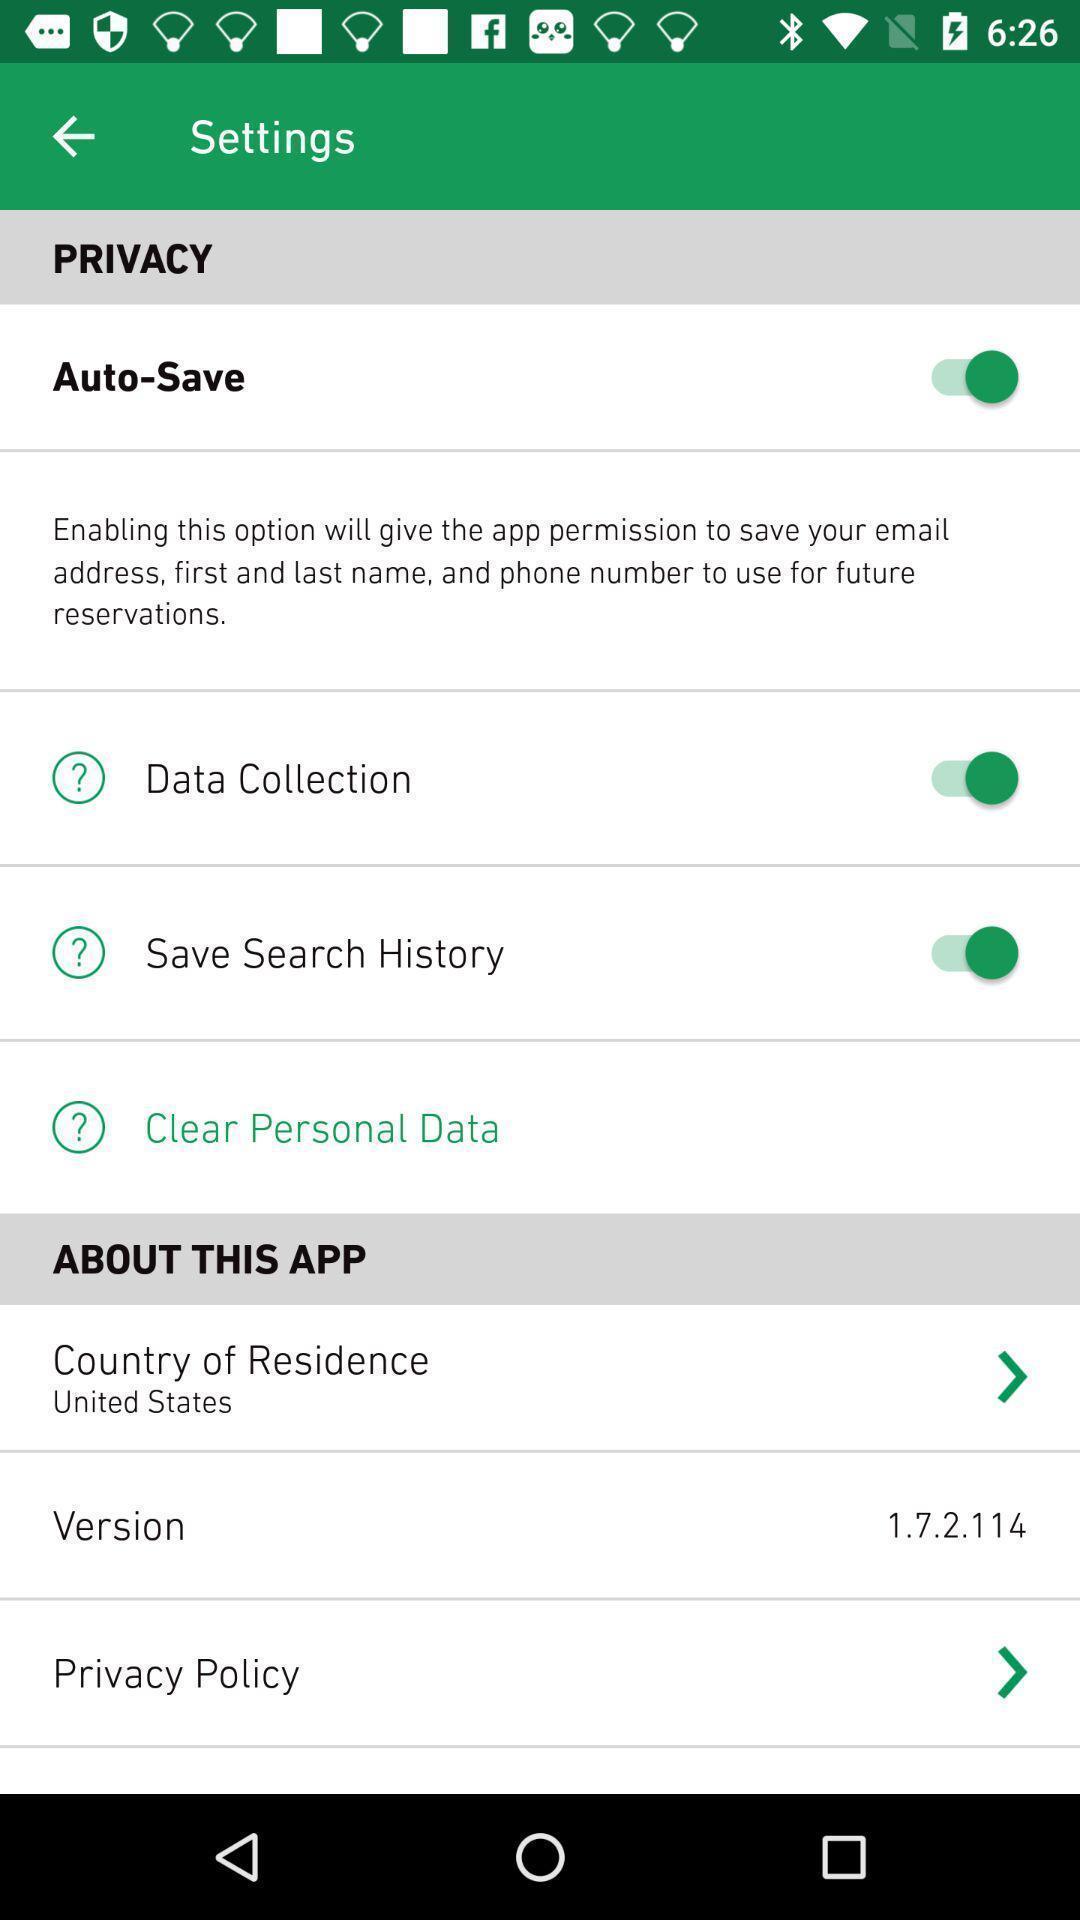Summarize the main components in this picture. Settings page with list of options. 